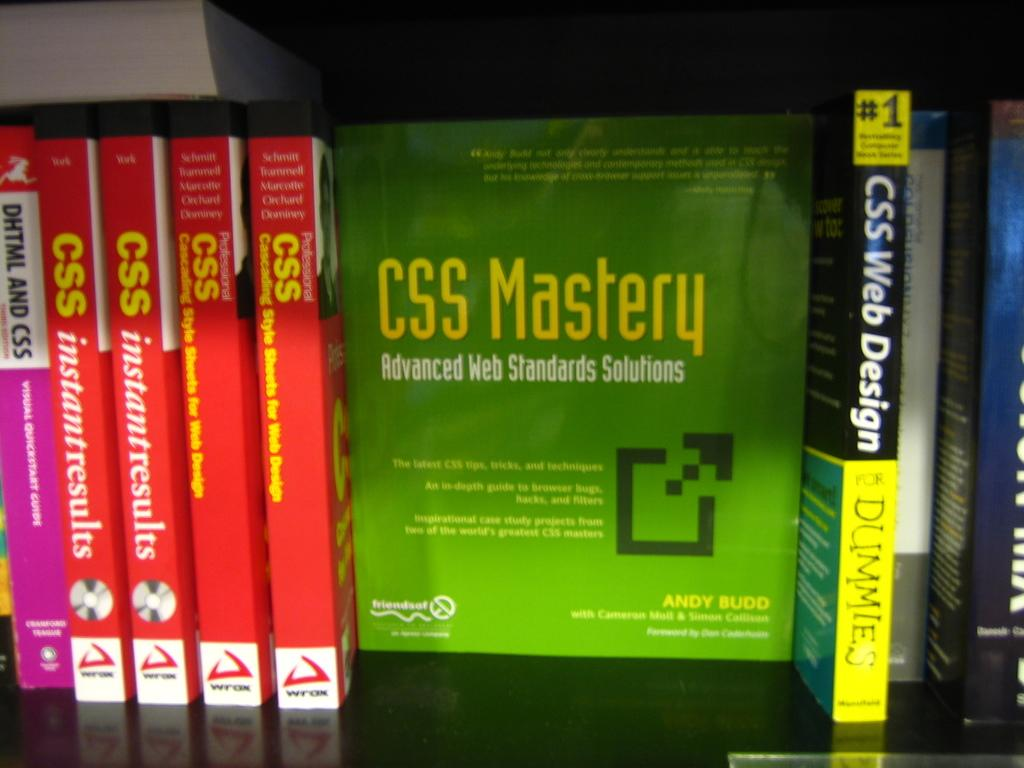<image>
Provide a brief description of the given image. Books on CSS, including CSS Mastery, are lined up on a shelf. 